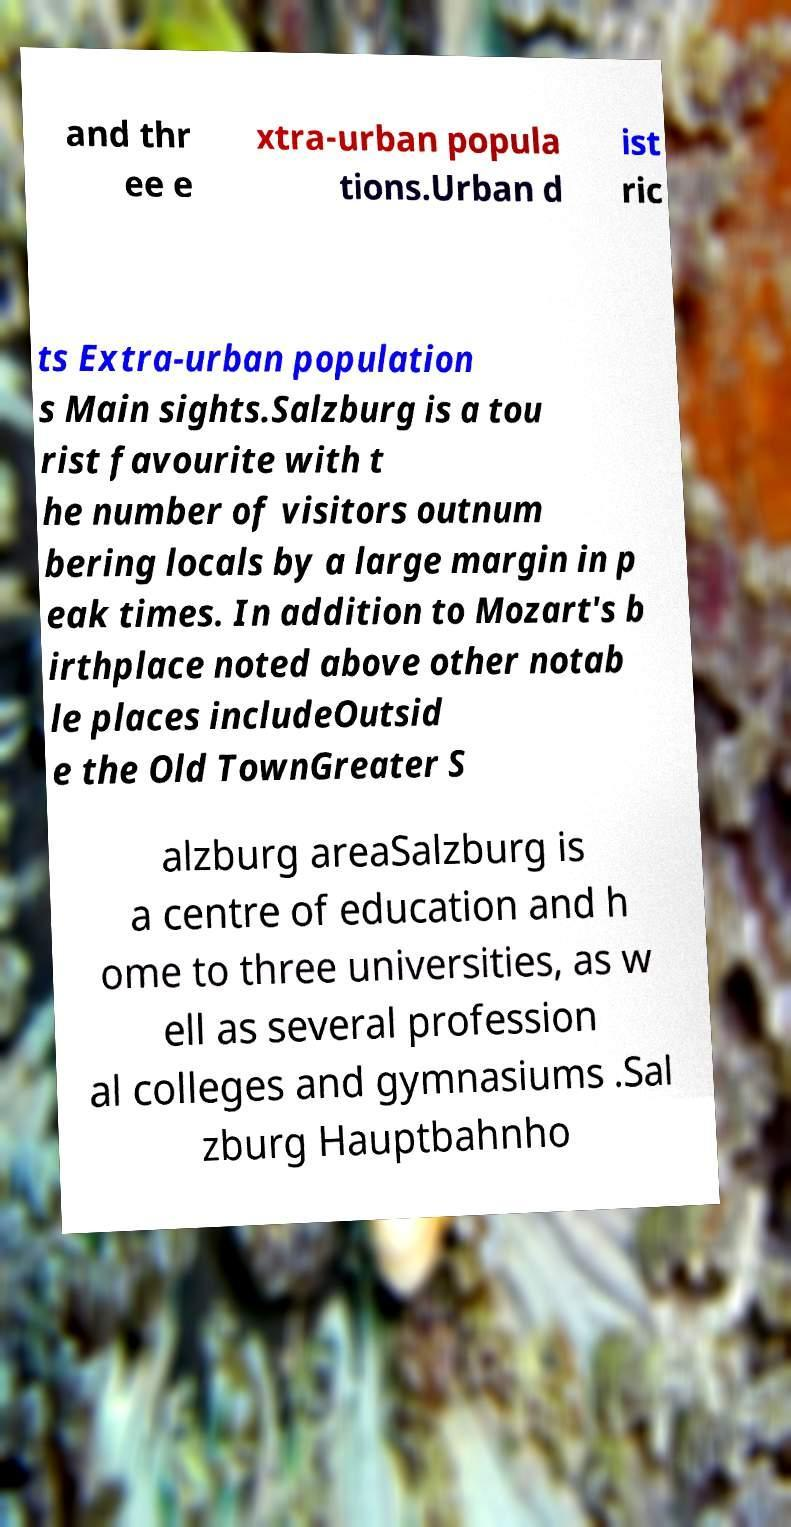Could you assist in decoding the text presented in this image and type it out clearly? and thr ee e xtra-urban popula tions.Urban d ist ric ts Extra-urban population s Main sights.Salzburg is a tou rist favourite with t he number of visitors outnum bering locals by a large margin in p eak times. In addition to Mozart's b irthplace noted above other notab le places includeOutsid e the Old TownGreater S alzburg areaSalzburg is a centre of education and h ome to three universities, as w ell as several profession al colleges and gymnasiums .Sal zburg Hauptbahnho 